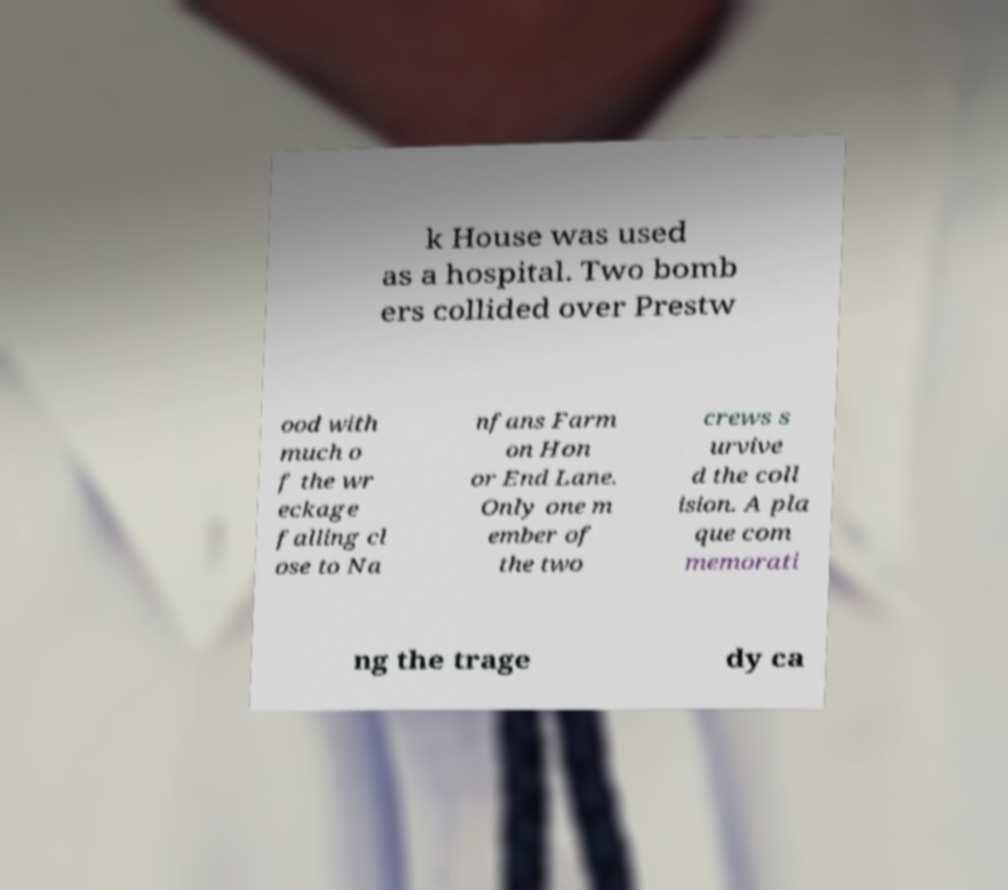There's text embedded in this image that I need extracted. Can you transcribe it verbatim? k House was used as a hospital. Two bomb ers collided over Prestw ood with much o f the wr eckage falling cl ose to Na nfans Farm on Hon or End Lane. Only one m ember of the two crews s urvive d the coll ision. A pla que com memorati ng the trage dy ca 